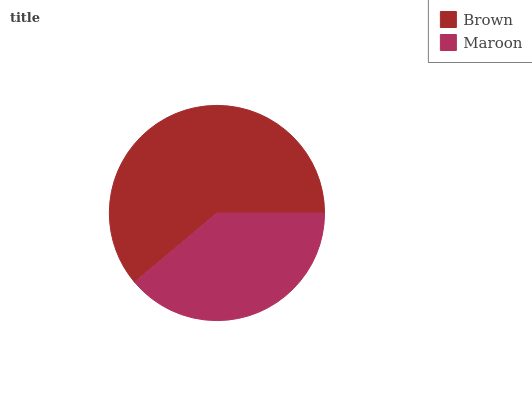Is Maroon the minimum?
Answer yes or no. Yes. Is Brown the maximum?
Answer yes or no. Yes. Is Maroon the maximum?
Answer yes or no. No. Is Brown greater than Maroon?
Answer yes or no. Yes. Is Maroon less than Brown?
Answer yes or no. Yes. Is Maroon greater than Brown?
Answer yes or no. No. Is Brown less than Maroon?
Answer yes or no. No. Is Brown the high median?
Answer yes or no. Yes. Is Maroon the low median?
Answer yes or no. Yes. Is Maroon the high median?
Answer yes or no. No. Is Brown the low median?
Answer yes or no. No. 